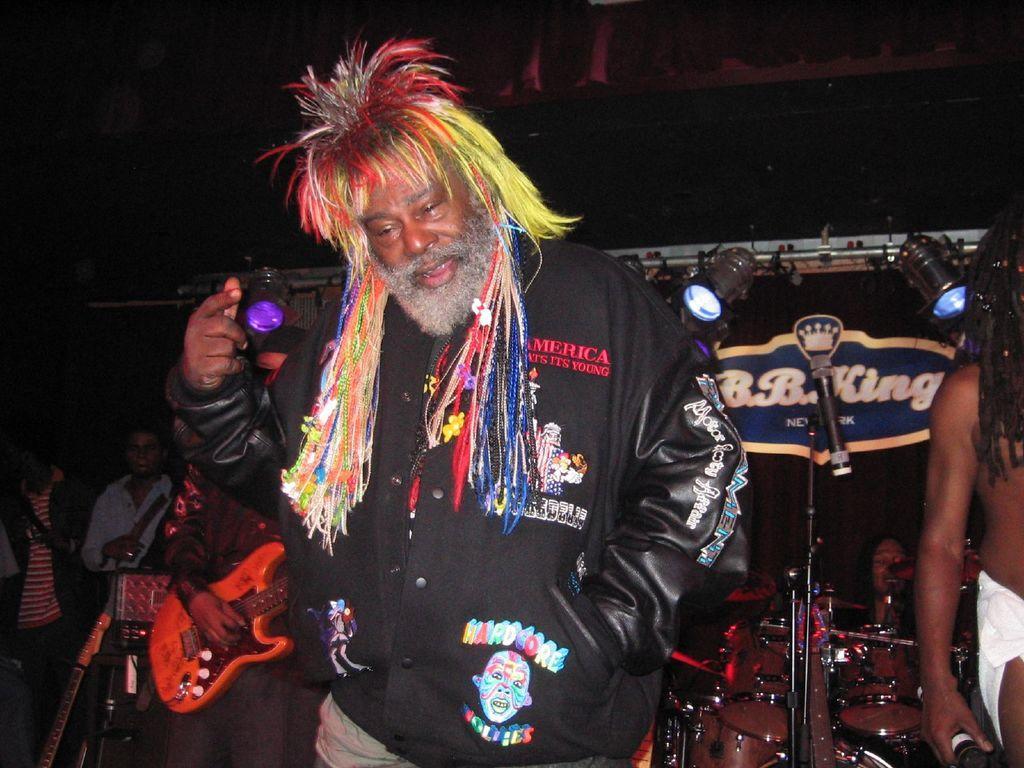Can you describe this image briefly? In this image a person is standing wearing a black jacket. Behind him person is playing guitar, drums. One person is standing here. There are lights , few other people in the background. 